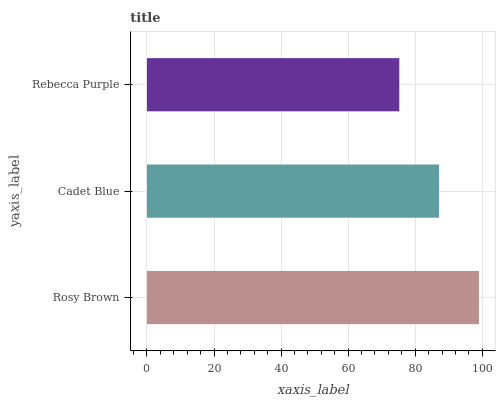Is Rebecca Purple the minimum?
Answer yes or no. Yes. Is Rosy Brown the maximum?
Answer yes or no. Yes. Is Cadet Blue the minimum?
Answer yes or no. No. Is Cadet Blue the maximum?
Answer yes or no. No. Is Rosy Brown greater than Cadet Blue?
Answer yes or no. Yes. Is Cadet Blue less than Rosy Brown?
Answer yes or no. Yes. Is Cadet Blue greater than Rosy Brown?
Answer yes or no. No. Is Rosy Brown less than Cadet Blue?
Answer yes or no. No. Is Cadet Blue the high median?
Answer yes or no. Yes. Is Cadet Blue the low median?
Answer yes or no. Yes. Is Rebecca Purple the high median?
Answer yes or no. No. Is Rosy Brown the low median?
Answer yes or no. No. 